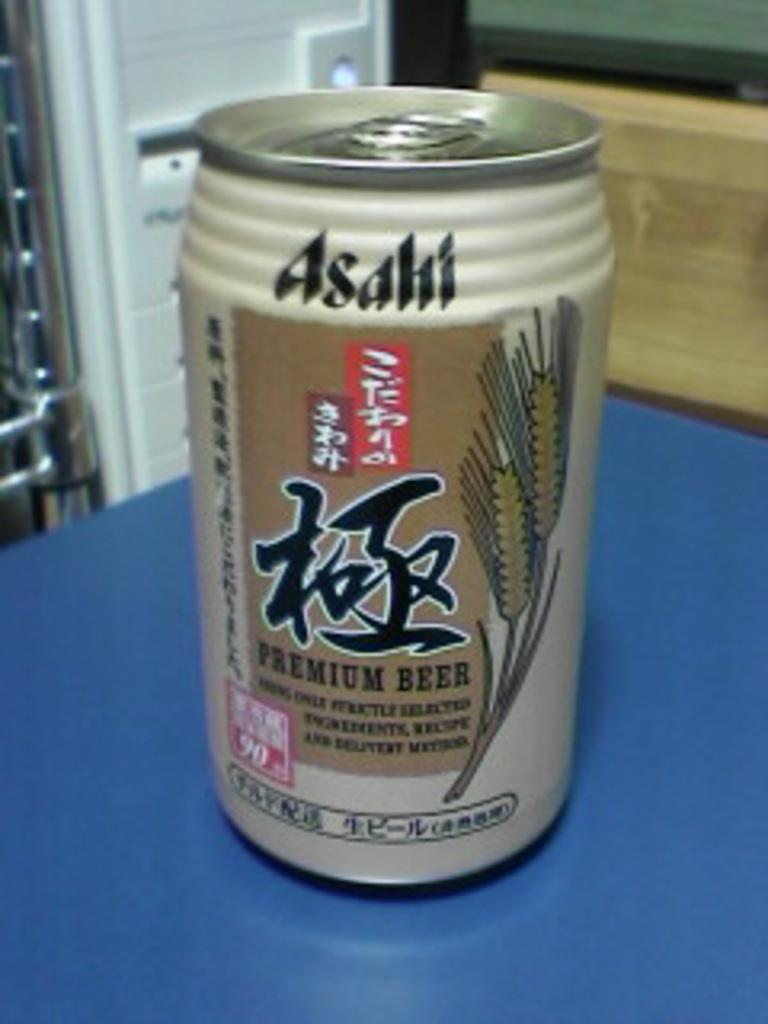<image>
Relay a brief, clear account of the picture shown. An Asaki beer rests on a kitchen counter. 